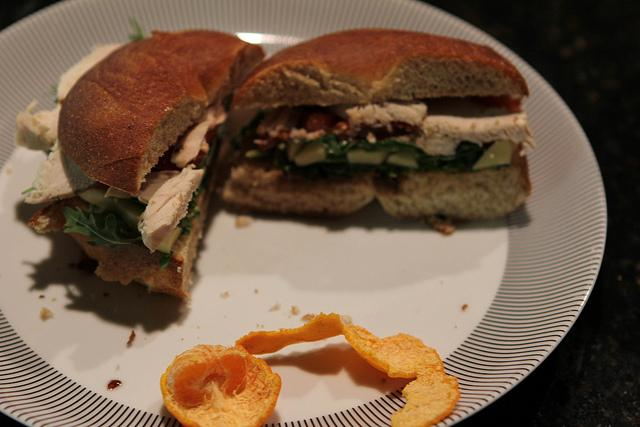Which part of this meal has a small portion? chips 